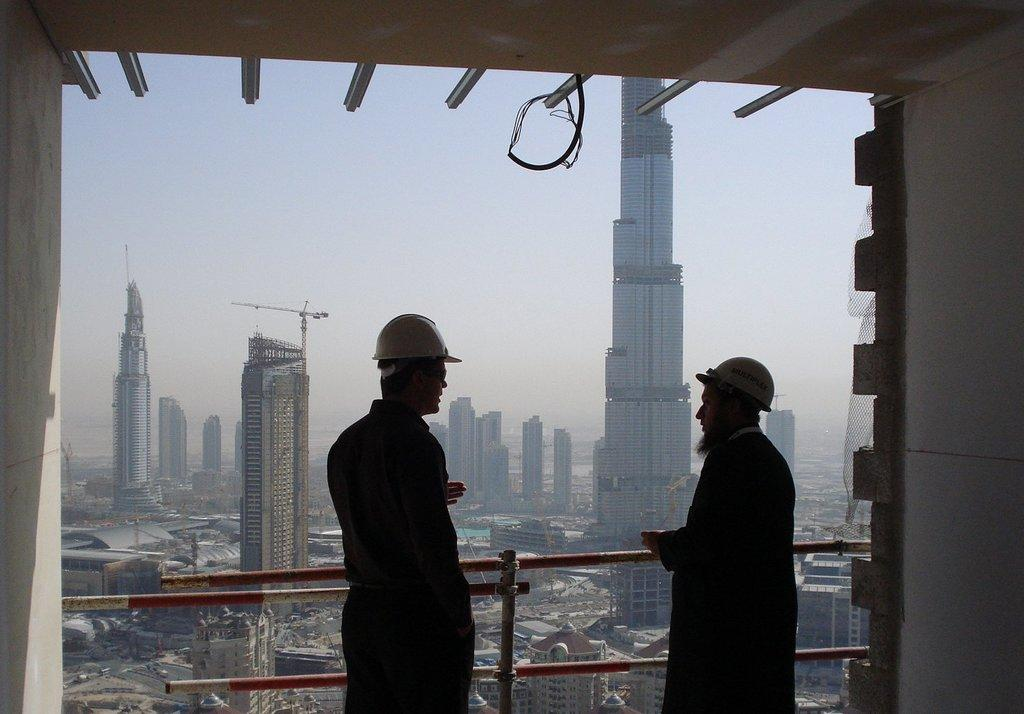How many people are in the image? There are two men in the image. What are the men wearing on their heads? The men are wearing helmets. What position are the men in? The men are standing. What type of structures can be seen in the image? There are buildings in the image. What objects are present that resemble long, thin bars? There are rods in the image. What can be seen in the distance behind the men and buildings? The sky is visible in the background of the image. Reasoning: Let' Let's think step by step in order to produce the conversation. We start by identifying the main subjects in the image, which are the two men. Then, we describe their appearance and position. Next, we mention the other objects and structures present in the image, such as the buildings and rods. Finally, we describe the background of the image, which is the sky. Absurd Question/Answer: What type of shoe is the giant wearing in the image? There are no giants or shoes present in the image. What type of pest can be seen crawling on the buildings in the image? There are no pests visible in the image; only the men, buildings, rods, and sky are present. 